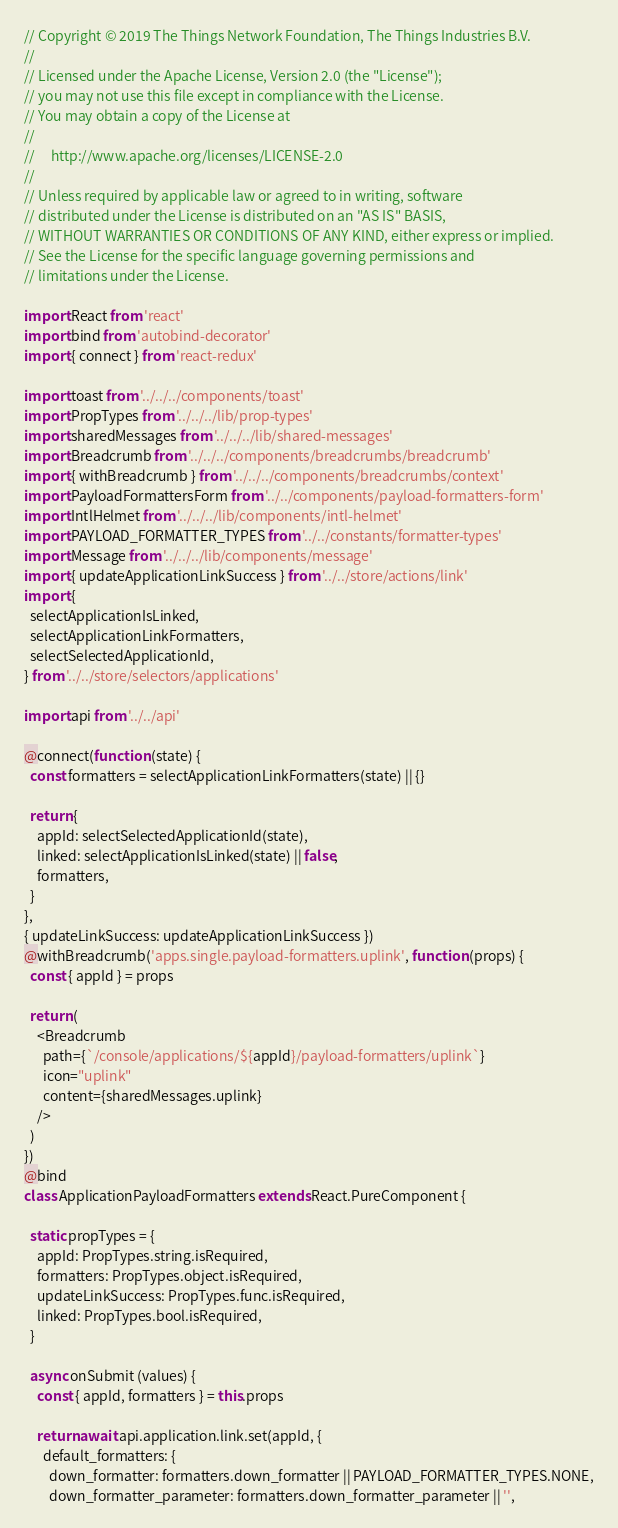<code> <loc_0><loc_0><loc_500><loc_500><_JavaScript_>// Copyright © 2019 The Things Network Foundation, The Things Industries B.V.
//
// Licensed under the Apache License, Version 2.0 (the "License");
// you may not use this file except in compliance with the License.
// You may obtain a copy of the License at
//
//     http://www.apache.org/licenses/LICENSE-2.0
//
// Unless required by applicable law or agreed to in writing, software
// distributed under the License is distributed on an "AS IS" BASIS,
// WITHOUT WARRANTIES OR CONDITIONS OF ANY KIND, either express or implied.
// See the License for the specific language governing permissions and
// limitations under the License.

import React from 'react'
import bind from 'autobind-decorator'
import { connect } from 'react-redux'

import toast from '../../../components/toast'
import PropTypes from '../../../lib/prop-types'
import sharedMessages from '../../../lib/shared-messages'
import Breadcrumb from '../../../components/breadcrumbs/breadcrumb'
import { withBreadcrumb } from '../../../components/breadcrumbs/context'
import PayloadFormattersForm from '../../components/payload-formatters-form'
import IntlHelmet from '../../../lib/components/intl-helmet'
import PAYLOAD_FORMATTER_TYPES from '../../constants/formatter-types'
import Message from '../../../lib/components/message'
import { updateApplicationLinkSuccess } from '../../store/actions/link'
import {
  selectApplicationIsLinked,
  selectApplicationLinkFormatters,
  selectSelectedApplicationId,
} from '../../store/selectors/applications'

import api from '../../api'

@connect(function (state) {
  const formatters = selectApplicationLinkFormatters(state) || {}

  return {
    appId: selectSelectedApplicationId(state),
    linked: selectApplicationIsLinked(state) || false,
    formatters,
  }
},
{ updateLinkSuccess: updateApplicationLinkSuccess })
@withBreadcrumb('apps.single.payload-formatters.uplink', function (props) {
  const { appId } = props

  return (
    <Breadcrumb
      path={`/console/applications/${appId}/payload-formatters/uplink`}
      icon="uplink"
      content={sharedMessages.uplink}
    />
  )
})
@bind
class ApplicationPayloadFormatters extends React.PureComponent {

  static propTypes = {
    appId: PropTypes.string.isRequired,
    formatters: PropTypes.object.isRequired,
    updateLinkSuccess: PropTypes.func.isRequired,
    linked: PropTypes.bool.isRequired,
  }

  async onSubmit (values) {
    const { appId, formatters } = this.props

    return await api.application.link.set(appId, {
      default_formatters: {
        down_formatter: formatters.down_formatter || PAYLOAD_FORMATTER_TYPES.NONE,
        down_formatter_parameter: formatters.down_formatter_parameter || '',</code> 